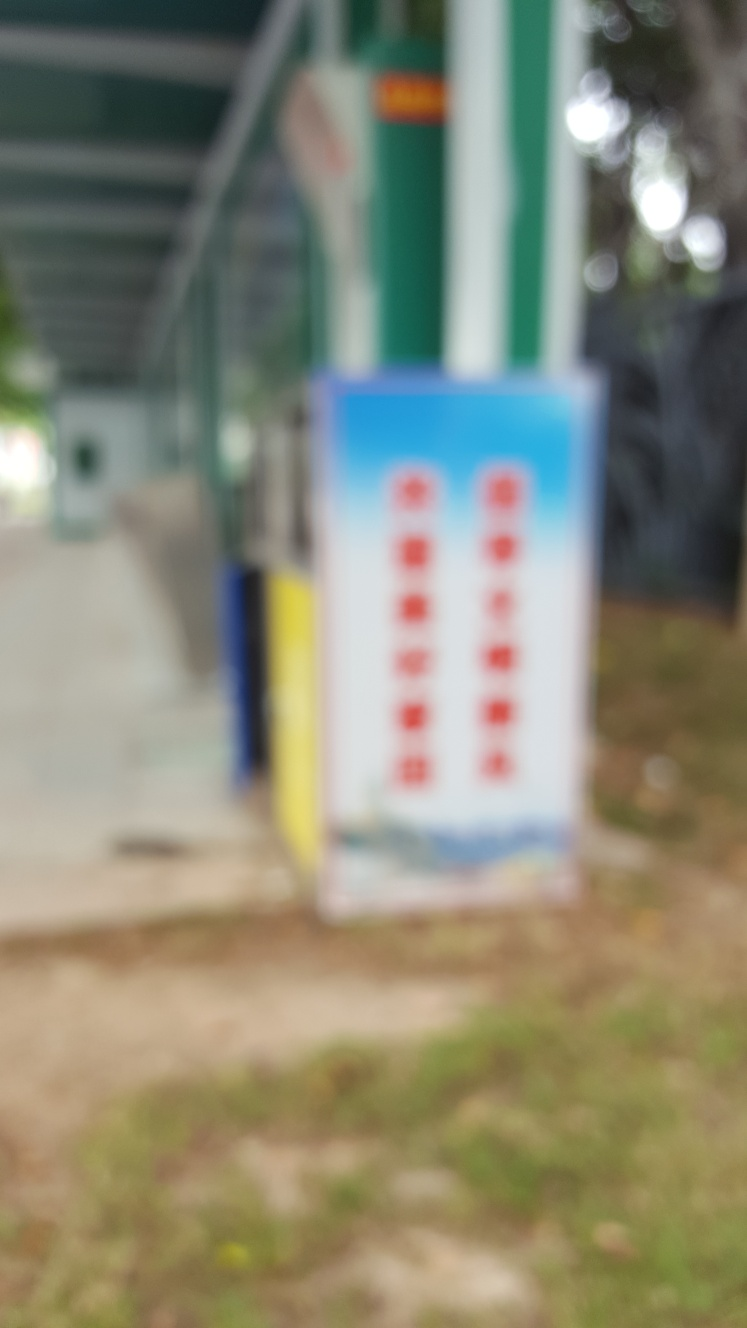Is there anything in the photo that might indicate what time of day it is? It's difficult to determine the exact time of day due to the blurriness and lack of shadow details. However, the overall brightness and the diffused light suggest it could be taken during daytime under an overcast sky or in a shaded area. 